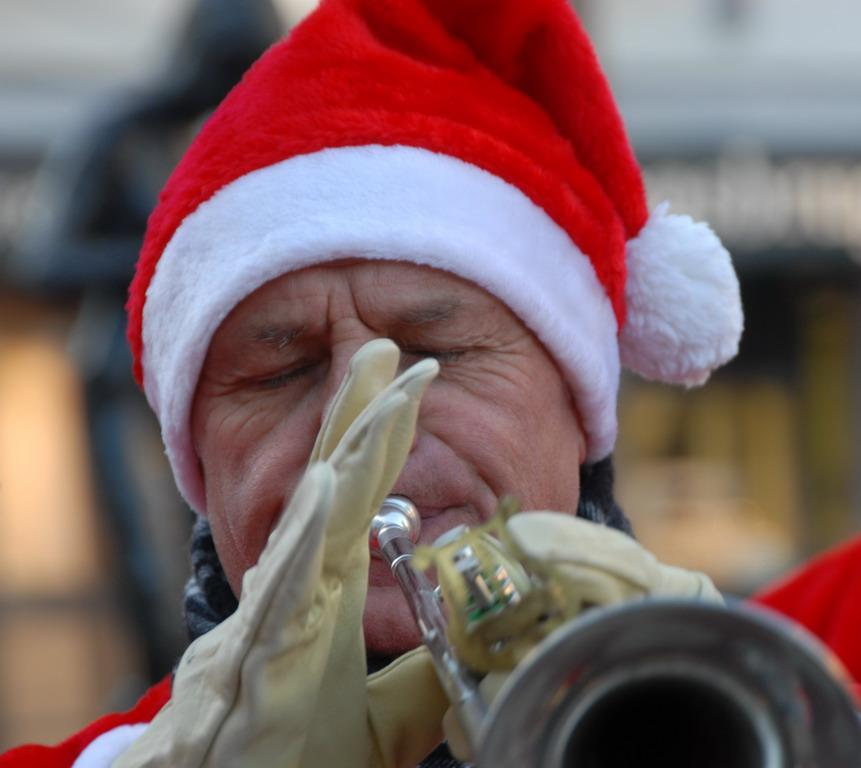What is the main subject of the image? There is a person in the image. What is the person doing in the image? The person is holding a musical instrument. Can you describe the background of the image? There are other objects in the background of the image. What type of bomb can be seen in the image? There is no bomb present in the image. Is the person swimming in the image? There is no indication of swimming in the image; the person is holding a musical instrument. 